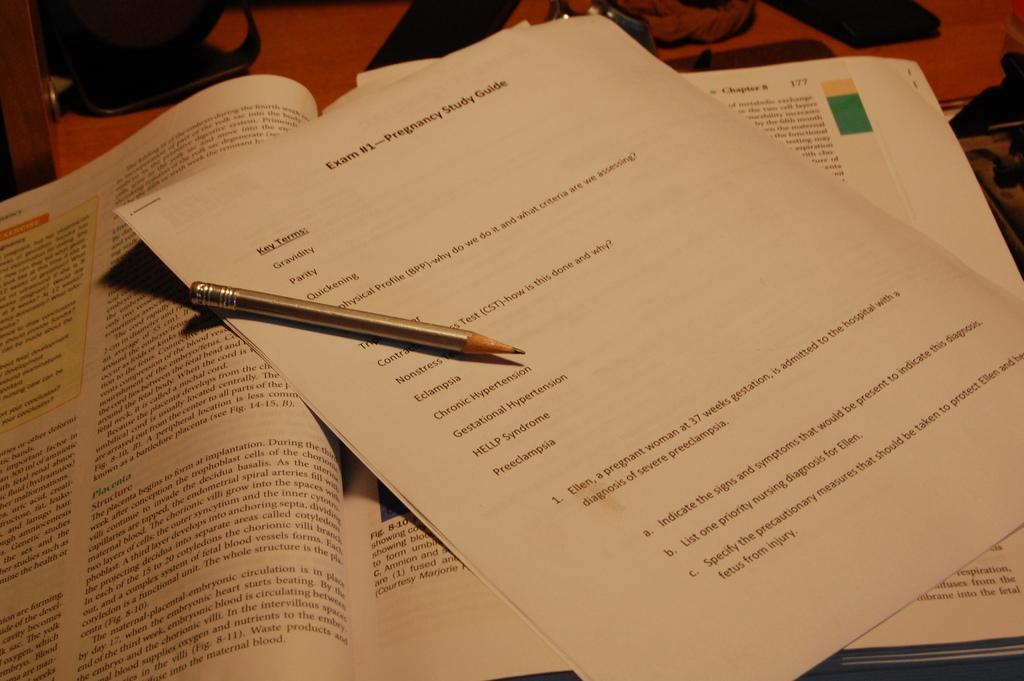Could you give a brief overview of what you see in this image? In this picture, there is a book, papers and a pencil. 